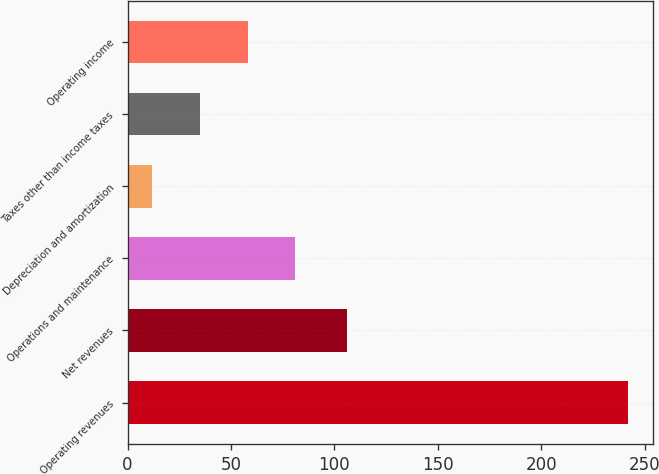Convert chart to OTSL. <chart><loc_0><loc_0><loc_500><loc_500><bar_chart><fcel>Operating revenues<fcel>Net revenues<fcel>Operations and maintenance<fcel>Depreciation and amortization<fcel>Taxes other than income taxes<fcel>Operating income<nl><fcel>242<fcel>106<fcel>81<fcel>12<fcel>35<fcel>58<nl></chart> 